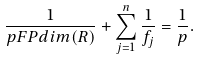<formula> <loc_0><loc_0><loc_500><loc_500>\frac { 1 } { p F P d i m ( R ) } + \sum _ { j = 1 } ^ { n } \frac { 1 } { f _ { j } } = \frac { 1 } { p } .</formula> 